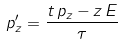<formula> <loc_0><loc_0><loc_500><loc_500>p _ { z } ^ { \prime } = \frac { t \, p _ { z } - z \, E } { \tau }</formula> 